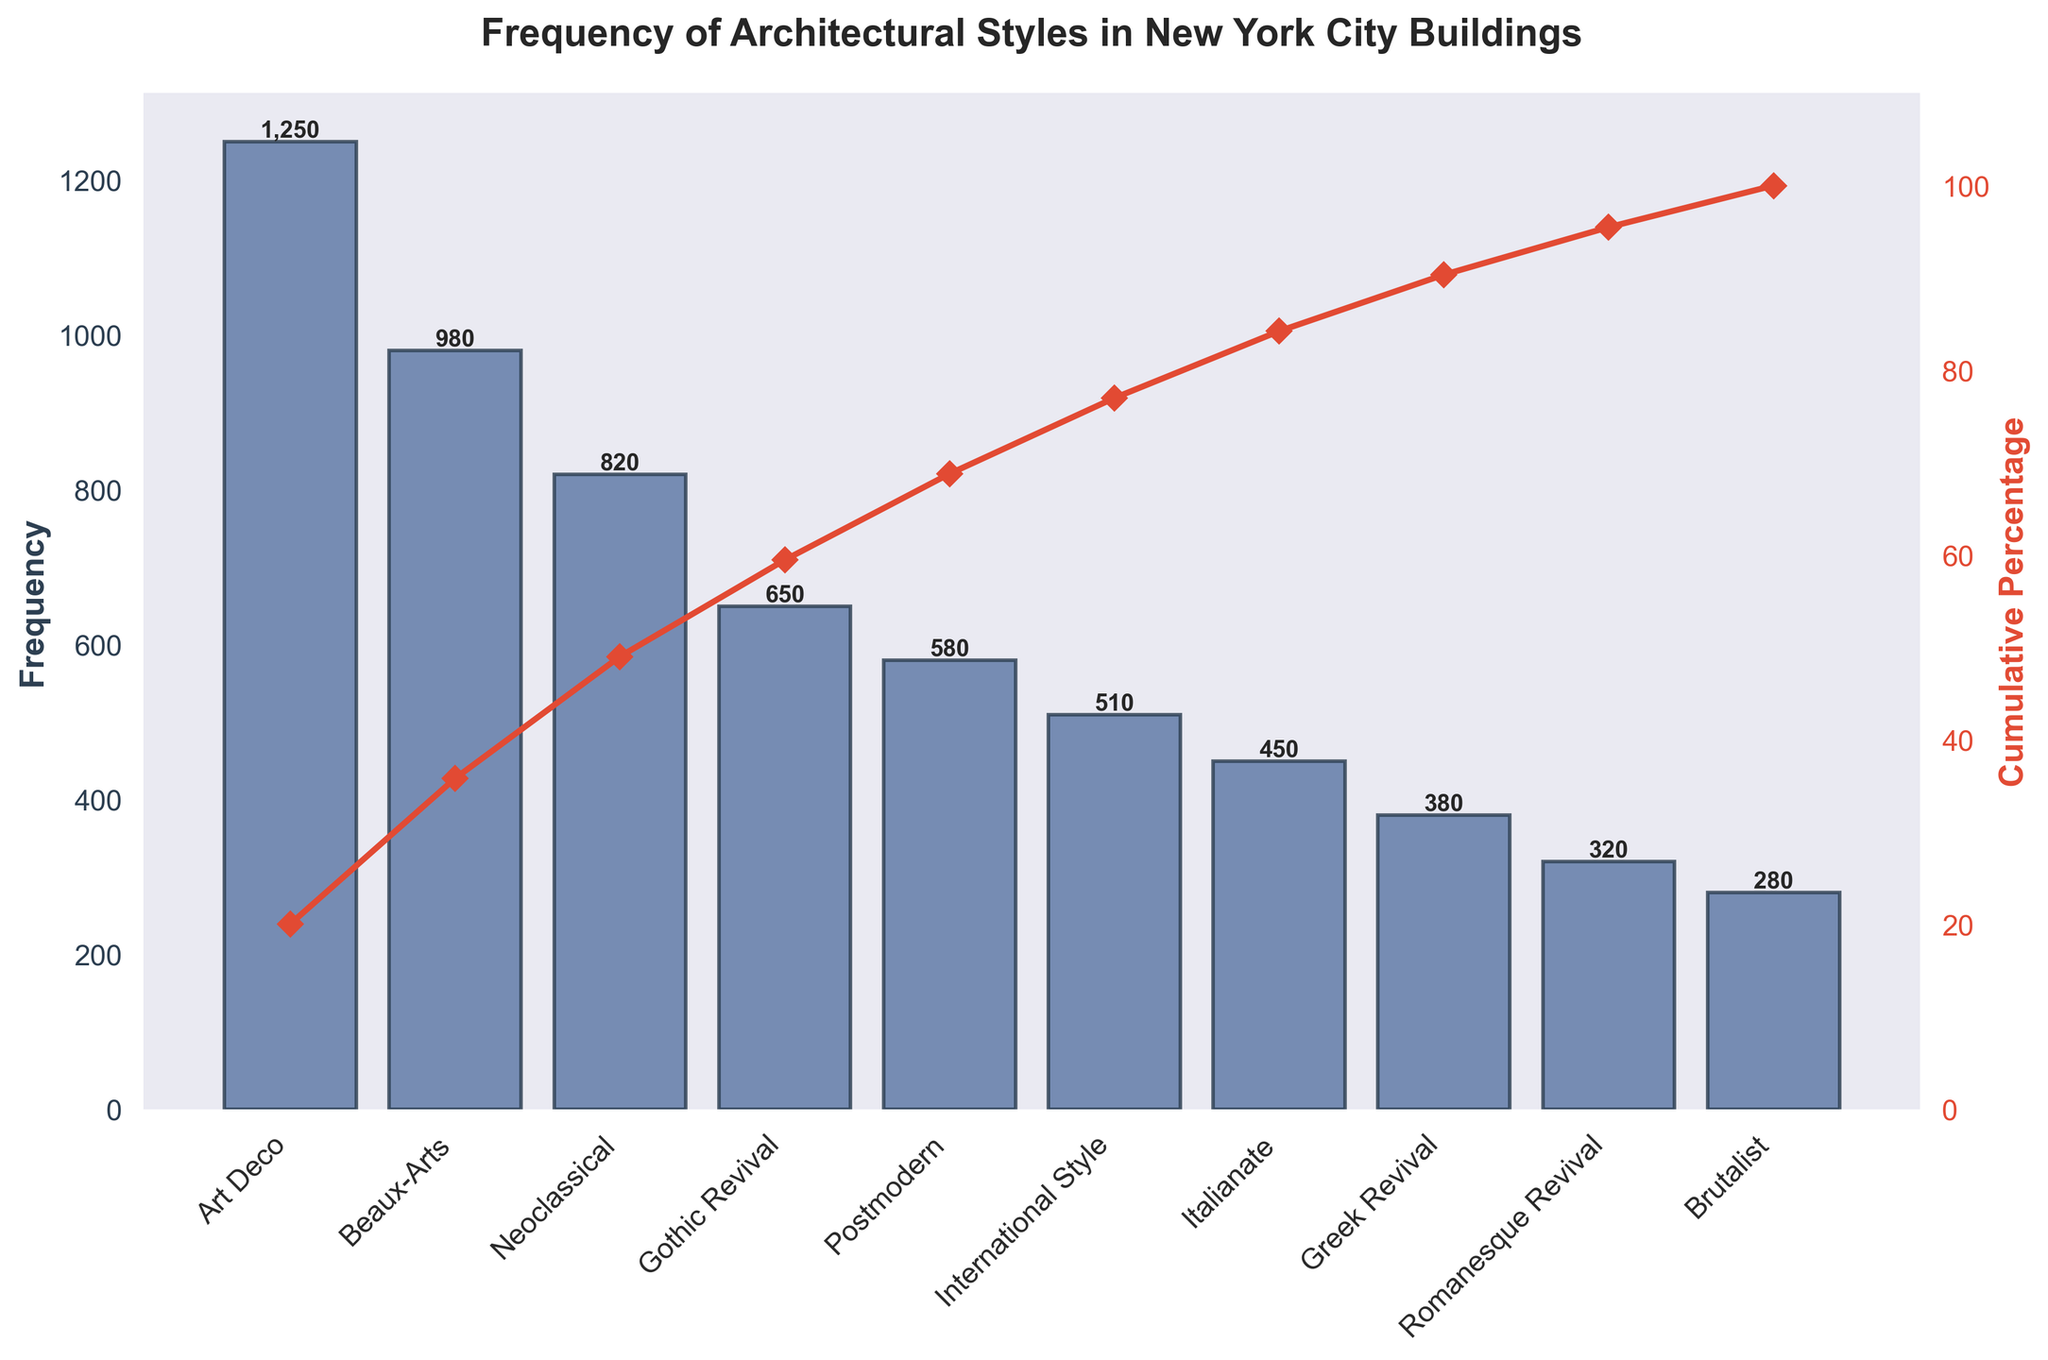what is the total frequency of buildings? Add up the frequency of all architectural styles: 1250 (Art Deco) + 980 (Beaux-Arts) + 820 (Neoclassical) + 650 (Gothic Revival) + 580 (Postmodern) + 510 (International Style) + 450 (Italianate) + 380 (Greek Revival) + 320 (Romanesque Revival) + 280 (Brutalist) = 6220
Answer: 6220 which architectural style has the highest frequency? Look at the height of the bar or the number label on top for each style to identify the tallest one, which is Art Deco at 1250
Answer: Art Deco how many buildings are in the Romanesque Revival style? Find the bar labeled "Romanesque Revival" and read the frequency number on top of it, which is 320
Answer: 320 which styles have a cumulative percentage over 50%? Observe the secondary y-axis (right side) for cumulative percentage and see where it crosses 50%. The styles Art Deco, Beaux-Arts, and Neoclassical collectively account for over 50%
Answer: Art Deco, Beaux-Arts, Neoclassical what is the frequency difference between Postmodern and International Style? Subtract the frequency of International Style (510) from Postmodern (580). The difference is 580 - 510 = 70
Answer: 70 at what frequency does the cumulative percentage cross 75%? Observe the secondary y-axis (right side) and find where the line crosses 75%. The styles accounting for up to that point are Art Deco (1250), Beaux-Arts (980), Neoclassical (820), and Gothic Revival (650). Summing these: 1250 + 980 + 820 + 650 = 3700
Answer: 3700 how many styles have a frequency less than 500? Count the number of bars with a height representing less than 500 buildings: Italianate, Greek Revival, Romanesque Revival, and Brutalist. Hence, there are 4 styles
Answer: 4 what is the cumulative percentage for Gothic Revival alone? Find the "Gothic Revival" label and trace its cumulative percentage line up to the secondary y-axis on the right, which reads about 55%
Answer: approximately 55% which architectural style has the smallest frequency? Find the shortest bar or check the label with the lowest value, which is Brutalist at 280
Answer: Brutalist how many styles have a frequency more than 800 but less than 1000? Count the number of bars falling within this range: Beaux-Arts (980) and Neoclassical (820). Thus, there are 2 styles
Answer: 2 